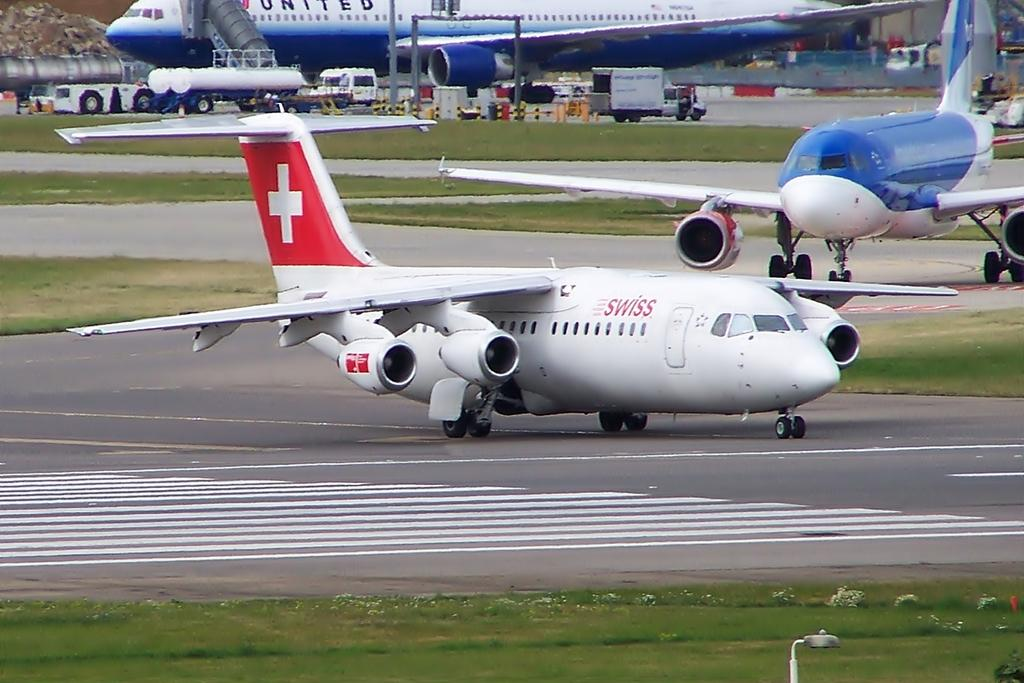<image>
Share a concise interpretation of the image provided. many airplanes can be seen here, including a Swiss air one 